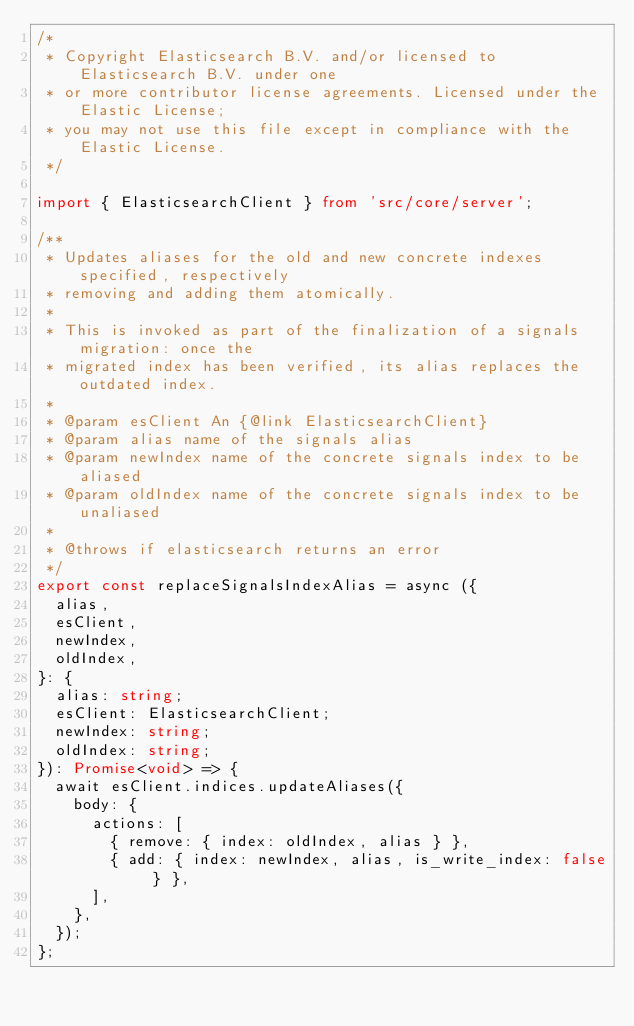<code> <loc_0><loc_0><loc_500><loc_500><_TypeScript_>/*
 * Copyright Elasticsearch B.V. and/or licensed to Elasticsearch B.V. under one
 * or more contributor license agreements. Licensed under the Elastic License;
 * you may not use this file except in compliance with the Elastic License.
 */

import { ElasticsearchClient } from 'src/core/server';

/**
 * Updates aliases for the old and new concrete indexes specified, respectively
 * removing and adding them atomically.
 *
 * This is invoked as part of the finalization of a signals migration: once the
 * migrated index has been verified, its alias replaces the outdated index.
 *
 * @param esClient An {@link ElasticsearchClient}
 * @param alias name of the signals alias
 * @param newIndex name of the concrete signals index to be aliased
 * @param oldIndex name of the concrete signals index to be unaliased
 *
 * @throws if elasticsearch returns an error
 */
export const replaceSignalsIndexAlias = async ({
  alias,
  esClient,
  newIndex,
  oldIndex,
}: {
  alias: string;
  esClient: ElasticsearchClient;
  newIndex: string;
  oldIndex: string;
}): Promise<void> => {
  await esClient.indices.updateAliases({
    body: {
      actions: [
        { remove: { index: oldIndex, alias } },
        { add: { index: newIndex, alias, is_write_index: false } },
      ],
    },
  });
};
</code> 